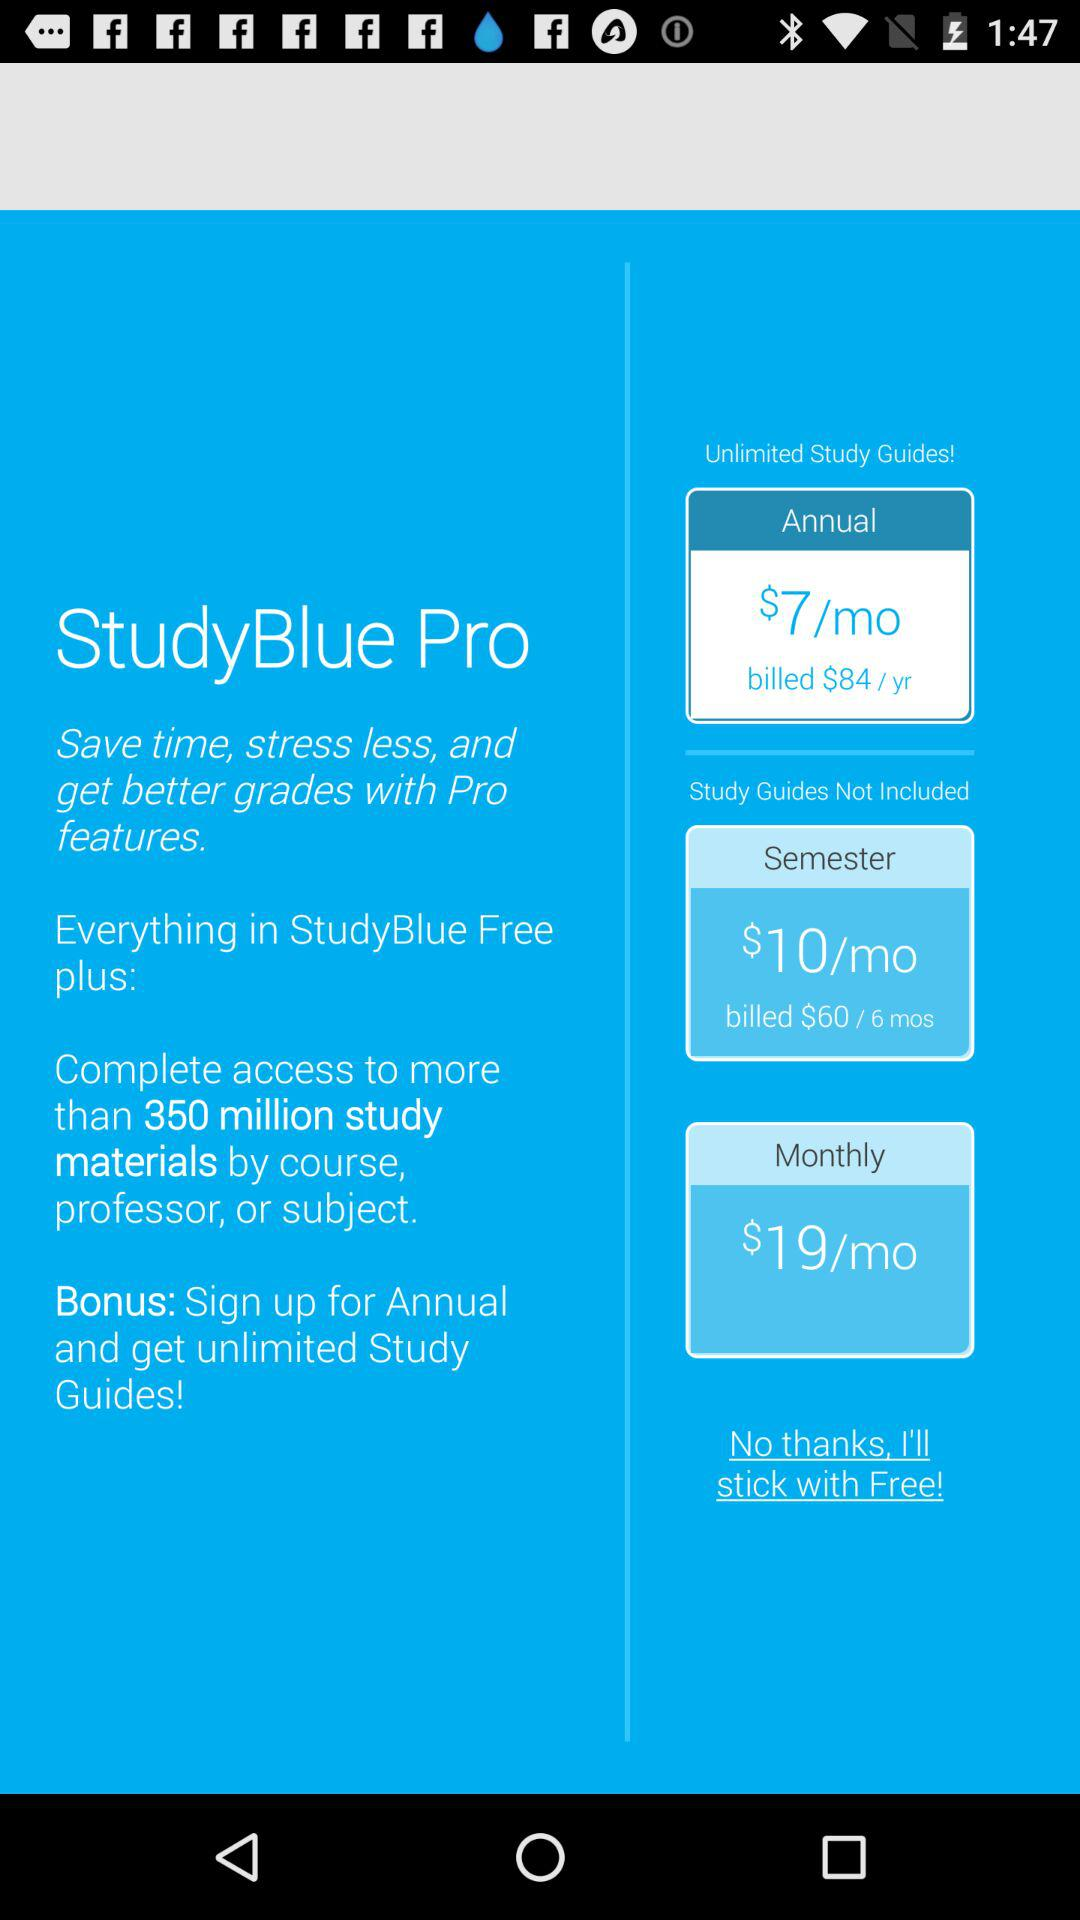What is the price for a six-month semester? The price is $60. 